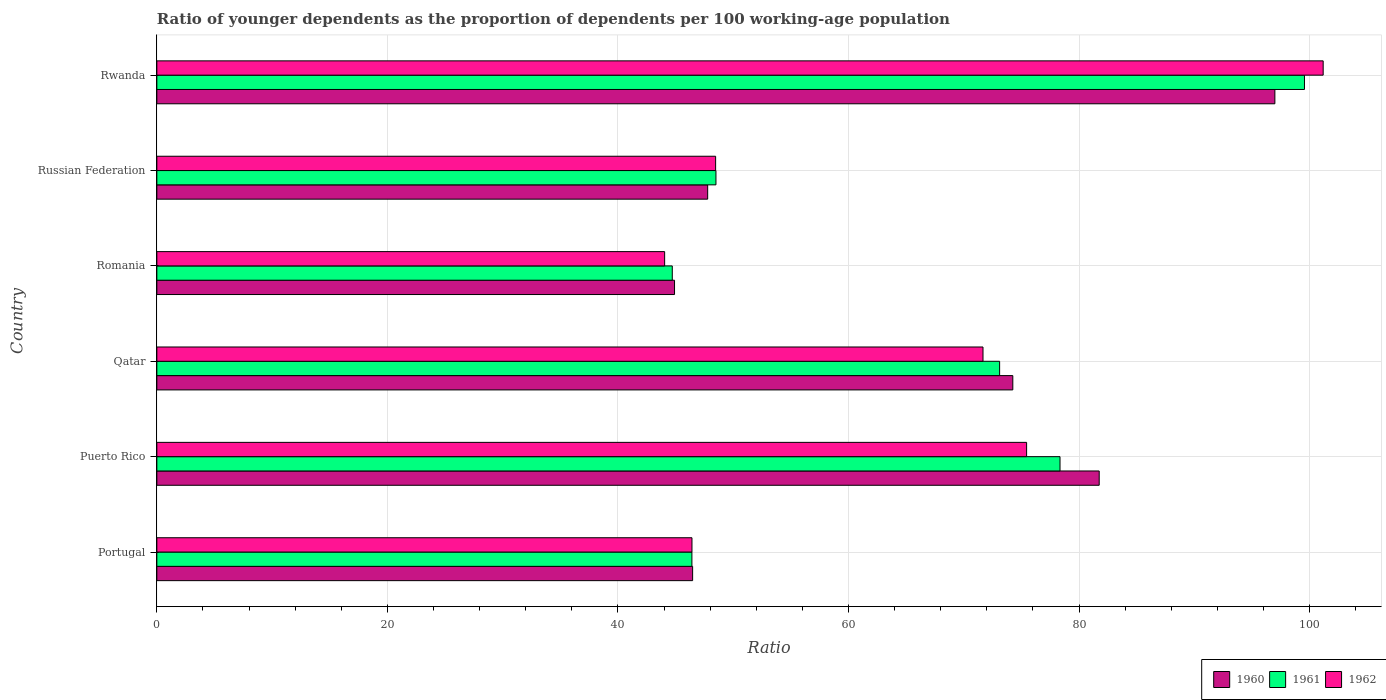How many different coloured bars are there?
Make the answer very short. 3. Are the number of bars per tick equal to the number of legend labels?
Offer a terse response. Yes. How many bars are there on the 2nd tick from the top?
Offer a terse response. 3. How many bars are there on the 6th tick from the bottom?
Offer a very short reply. 3. In how many cases, is the number of bars for a given country not equal to the number of legend labels?
Make the answer very short. 0. What is the age dependency ratio(young) in 1961 in Russian Federation?
Your answer should be compact. 48.5. Across all countries, what is the maximum age dependency ratio(young) in 1961?
Your answer should be compact. 99.56. Across all countries, what is the minimum age dependency ratio(young) in 1962?
Provide a succinct answer. 44.05. In which country was the age dependency ratio(young) in 1961 maximum?
Ensure brevity in your answer.  Rwanda. In which country was the age dependency ratio(young) in 1960 minimum?
Give a very brief answer. Romania. What is the total age dependency ratio(young) in 1962 in the graph?
Provide a succinct answer. 387.24. What is the difference between the age dependency ratio(young) in 1960 in Qatar and that in Rwanda?
Your answer should be very brief. -22.73. What is the difference between the age dependency ratio(young) in 1960 in Rwanda and the age dependency ratio(young) in 1961 in Puerto Rico?
Provide a short and direct response. 18.64. What is the average age dependency ratio(young) in 1960 per country?
Make the answer very short. 65.36. What is the difference between the age dependency ratio(young) in 1961 and age dependency ratio(young) in 1960 in Portugal?
Your answer should be very brief. -0.06. In how many countries, is the age dependency ratio(young) in 1960 greater than 72 ?
Your response must be concise. 3. What is the ratio of the age dependency ratio(young) in 1962 in Portugal to that in Rwanda?
Offer a very short reply. 0.46. Is the age dependency ratio(young) in 1961 in Qatar less than that in Rwanda?
Keep it short and to the point. Yes. What is the difference between the highest and the second highest age dependency ratio(young) in 1960?
Provide a succinct answer. 15.24. What is the difference between the highest and the lowest age dependency ratio(young) in 1960?
Ensure brevity in your answer.  52.08. Is the sum of the age dependency ratio(young) in 1960 in Romania and Russian Federation greater than the maximum age dependency ratio(young) in 1961 across all countries?
Offer a terse response. No. What does the 1st bar from the top in Russian Federation represents?
Keep it short and to the point. 1962. What does the 2nd bar from the bottom in Rwanda represents?
Your answer should be compact. 1961. Is it the case that in every country, the sum of the age dependency ratio(young) in 1962 and age dependency ratio(young) in 1961 is greater than the age dependency ratio(young) in 1960?
Offer a terse response. Yes. How many countries are there in the graph?
Keep it short and to the point. 6. What is the difference between two consecutive major ticks on the X-axis?
Provide a short and direct response. 20. Are the values on the major ticks of X-axis written in scientific E-notation?
Your answer should be very brief. No. Does the graph contain any zero values?
Provide a short and direct response. No. Does the graph contain grids?
Ensure brevity in your answer.  Yes. How many legend labels are there?
Provide a short and direct response. 3. What is the title of the graph?
Provide a succinct answer. Ratio of younger dependents as the proportion of dependents per 100 working-age population. Does "1982" appear as one of the legend labels in the graph?
Offer a terse response. No. What is the label or title of the X-axis?
Offer a terse response. Ratio. What is the Ratio in 1960 in Portugal?
Your answer should be very brief. 46.48. What is the Ratio of 1961 in Portugal?
Your answer should be very brief. 46.42. What is the Ratio in 1962 in Portugal?
Your answer should be compact. 46.42. What is the Ratio of 1960 in Puerto Rico?
Keep it short and to the point. 81.75. What is the Ratio of 1961 in Puerto Rico?
Offer a terse response. 78.35. What is the Ratio of 1962 in Puerto Rico?
Provide a succinct answer. 75.45. What is the Ratio of 1960 in Qatar?
Your answer should be compact. 74.25. What is the Ratio of 1961 in Qatar?
Offer a very short reply. 73.11. What is the Ratio of 1962 in Qatar?
Offer a terse response. 71.67. What is the Ratio of 1960 in Romania?
Your answer should be compact. 44.91. What is the Ratio in 1961 in Romania?
Your answer should be very brief. 44.71. What is the Ratio in 1962 in Romania?
Provide a short and direct response. 44.05. What is the Ratio in 1960 in Russian Federation?
Your response must be concise. 47.78. What is the Ratio of 1961 in Russian Federation?
Ensure brevity in your answer.  48.5. What is the Ratio in 1962 in Russian Federation?
Provide a short and direct response. 48.47. What is the Ratio of 1960 in Rwanda?
Keep it short and to the point. 96.99. What is the Ratio of 1961 in Rwanda?
Give a very brief answer. 99.56. What is the Ratio of 1962 in Rwanda?
Keep it short and to the point. 101.18. Across all countries, what is the maximum Ratio in 1960?
Make the answer very short. 96.99. Across all countries, what is the maximum Ratio of 1961?
Provide a succinct answer. 99.56. Across all countries, what is the maximum Ratio in 1962?
Your answer should be compact. 101.18. Across all countries, what is the minimum Ratio of 1960?
Your answer should be compact. 44.91. Across all countries, what is the minimum Ratio in 1961?
Provide a succinct answer. 44.71. Across all countries, what is the minimum Ratio of 1962?
Offer a terse response. 44.05. What is the total Ratio of 1960 in the graph?
Give a very brief answer. 392.16. What is the total Ratio in 1961 in the graph?
Ensure brevity in your answer.  390.65. What is the total Ratio in 1962 in the graph?
Ensure brevity in your answer.  387.24. What is the difference between the Ratio of 1960 in Portugal and that in Puerto Rico?
Ensure brevity in your answer.  -35.27. What is the difference between the Ratio of 1961 in Portugal and that in Puerto Rico?
Offer a terse response. -31.93. What is the difference between the Ratio in 1962 in Portugal and that in Puerto Rico?
Offer a terse response. -29.03. What is the difference between the Ratio of 1960 in Portugal and that in Qatar?
Give a very brief answer. -27.78. What is the difference between the Ratio in 1961 in Portugal and that in Qatar?
Your answer should be very brief. -26.69. What is the difference between the Ratio of 1962 in Portugal and that in Qatar?
Your answer should be compact. -25.25. What is the difference between the Ratio in 1960 in Portugal and that in Romania?
Offer a terse response. 1.57. What is the difference between the Ratio in 1961 in Portugal and that in Romania?
Offer a very short reply. 1.7. What is the difference between the Ratio in 1962 in Portugal and that in Romania?
Offer a very short reply. 2.37. What is the difference between the Ratio in 1960 in Portugal and that in Russian Federation?
Your answer should be compact. -1.31. What is the difference between the Ratio of 1961 in Portugal and that in Russian Federation?
Provide a short and direct response. -2.09. What is the difference between the Ratio in 1962 in Portugal and that in Russian Federation?
Offer a very short reply. -2.05. What is the difference between the Ratio in 1960 in Portugal and that in Rwanda?
Provide a short and direct response. -50.51. What is the difference between the Ratio in 1961 in Portugal and that in Rwanda?
Keep it short and to the point. -53.14. What is the difference between the Ratio of 1962 in Portugal and that in Rwanda?
Ensure brevity in your answer.  -54.76. What is the difference between the Ratio in 1960 in Puerto Rico and that in Qatar?
Your answer should be compact. 7.49. What is the difference between the Ratio of 1961 in Puerto Rico and that in Qatar?
Provide a short and direct response. 5.24. What is the difference between the Ratio in 1962 in Puerto Rico and that in Qatar?
Ensure brevity in your answer.  3.78. What is the difference between the Ratio in 1960 in Puerto Rico and that in Romania?
Your answer should be compact. 36.84. What is the difference between the Ratio in 1961 in Puerto Rico and that in Romania?
Make the answer very short. 33.64. What is the difference between the Ratio of 1962 in Puerto Rico and that in Romania?
Offer a terse response. 31.4. What is the difference between the Ratio in 1960 in Puerto Rico and that in Russian Federation?
Provide a succinct answer. 33.96. What is the difference between the Ratio in 1961 in Puerto Rico and that in Russian Federation?
Give a very brief answer. 29.85. What is the difference between the Ratio of 1962 in Puerto Rico and that in Russian Federation?
Your answer should be compact. 26.98. What is the difference between the Ratio in 1960 in Puerto Rico and that in Rwanda?
Your answer should be very brief. -15.24. What is the difference between the Ratio of 1961 in Puerto Rico and that in Rwanda?
Make the answer very short. -21.21. What is the difference between the Ratio of 1962 in Puerto Rico and that in Rwanda?
Offer a very short reply. -25.73. What is the difference between the Ratio in 1960 in Qatar and that in Romania?
Offer a very short reply. 29.35. What is the difference between the Ratio in 1961 in Qatar and that in Romania?
Keep it short and to the point. 28.4. What is the difference between the Ratio of 1962 in Qatar and that in Romania?
Your answer should be compact. 27.62. What is the difference between the Ratio in 1960 in Qatar and that in Russian Federation?
Ensure brevity in your answer.  26.47. What is the difference between the Ratio of 1961 in Qatar and that in Russian Federation?
Ensure brevity in your answer.  24.61. What is the difference between the Ratio of 1962 in Qatar and that in Russian Federation?
Your answer should be compact. 23.2. What is the difference between the Ratio in 1960 in Qatar and that in Rwanda?
Provide a succinct answer. -22.73. What is the difference between the Ratio in 1961 in Qatar and that in Rwanda?
Your response must be concise. -26.44. What is the difference between the Ratio of 1962 in Qatar and that in Rwanda?
Give a very brief answer. -29.51. What is the difference between the Ratio in 1960 in Romania and that in Russian Federation?
Ensure brevity in your answer.  -2.88. What is the difference between the Ratio in 1961 in Romania and that in Russian Federation?
Keep it short and to the point. -3.79. What is the difference between the Ratio of 1962 in Romania and that in Russian Federation?
Your answer should be very brief. -4.42. What is the difference between the Ratio of 1960 in Romania and that in Rwanda?
Your answer should be very brief. -52.08. What is the difference between the Ratio of 1961 in Romania and that in Rwanda?
Offer a very short reply. -54.84. What is the difference between the Ratio in 1962 in Romania and that in Rwanda?
Your answer should be very brief. -57.13. What is the difference between the Ratio of 1960 in Russian Federation and that in Rwanda?
Your response must be concise. -49.2. What is the difference between the Ratio of 1961 in Russian Federation and that in Rwanda?
Offer a terse response. -51.05. What is the difference between the Ratio of 1962 in Russian Federation and that in Rwanda?
Your answer should be compact. -52.71. What is the difference between the Ratio in 1960 in Portugal and the Ratio in 1961 in Puerto Rico?
Provide a succinct answer. -31.87. What is the difference between the Ratio of 1960 in Portugal and the Ratio of 1962 in Puerto Rico?
Make the answer very short. -28.97. What is the difference between the Ratio in 1961 in Portugal and the Ratio in 1962 in Puerto Rico?
Offer a terse response. -29.04. What is the difference between the Ratio in 1960 in Portugal and the Ratio in 1961 in Qatar?
Provide a succinct answer. -26.63. What is the difference between the Ratio of 1960 in Portugal and the Ratio of 1962 in Qatar?
Your answer should be very brief. -25.19. What is the difference between the Ratio in 1961 in Portugal and the Ratio in 1962 in Qatar?
Provide a short and direct response. -25.25. What is the difference between the Ratio in 1960 in Portugal and the Ratio in 1961 in Romania?
Ensure brevity in your answer.  1.76. What is the difference between the Ratio in 1960 in Portugal and the Ratio in 1962 in Romania?
Make the answer very short. 2.43. What is the difference between the Ratio of 1961 in Portugal and the Ratio of 1962 in Romania?
Offer a very short reply. 2.37. What is the difference between the Ratio in 1960 in Portugal and the Ratio in 1961 in Russian Federation?
Ensure brevity in your answer.  -2.02. What is the difference between the Ratio of 1960 in Portugal and the Ratio of 1962 in Russian Federation?
Make the answer very short. -1.99. What is the difference between the Ratio in 1961 in Portugal and the Ratio in 1962 in Russian Federation?
Offer a very short reply. -2.06. What is the difference between the Ratio in 1960 in Portugal and the Ratio in 1961 in Rwanda?
Give a very brief answer. -53.08. What is the difference between the Ratio of 1960 in Portugal and the Ratio of 1962 in Rwanda?
Your response must be concise. -54.7. What is the difference between the Ratio in 1961 in Portugal and the Ratio in 1962 in Rwanda?
Offer a terse response. -54.76. What is the difference between the Ratio in 1960 in Puerto Rico and the Ratio in 1961 in Qatar?
Offer a terse response. 8.64. What is the difference between the Ratio in 1960 in Puerto Rico and the Ratio in 1962 in Qatar?
Ensure brevity in your answer.  10.08. What is the difference between the Ratio in 1961 in Puerto Rico and the Ratio in 1962 in Qatar?
Keep it short and to the point. 6.68. What is the difference between the Ratio of 1960 in Puerto Rico and the Ratio of 1961 in Romania?
Ensure brevity in your answer.  37.04. What is the difference between the Ratio of 1960 in Puerto Rico and the Ratio of 1962 in Romania?
Make the answer very short. 37.7. What is the difference between the Ratio of 1961 in Puerto Rico and the Ratio of 1962 in Romania?
Give a very brief answer. 34.3. What is the difference between the Ratio in 1960 in Puerto Rico and the Ratio in 1961 in Russian Federation?
Offer a terse response. 33.25. What is the difference between the Ratio in 1960 in Puerto Rico and the Ratio in 1962 in Russian Federation?
Offer a terse response. 33.28. What is the difference between the Ratio of 1961 in Puerto Rico and the Ratio of 1962 in Russian Federation?
Your response must be concise. 29.88. What is the difference between the Ratio in 1960 in Puerto Rico and the Ratio in 1961 in Rwanda?
Offer a very short reply. -17.81. What is the difference between the Ratio in 1960 in Puerto Rico and the Ratio in 1962 in Rwanda?
Your response must be concise. -19.43. What is the difference between the Ratio in 1961 in Puerto Rico and the Ratio in 1962 in Rwanda?
Offer a terse response. -22.83. What is the difference between the Ratio in 1960 in Qatar and the Ratio in 1961 in Romania?
Your answer should be compact. 29.54. What is the difference between the Ratio in 1960 in Qatar and the Ratio in 1962 in Romania?
Provide a short and direct response. 30.2. What is the difference between the Ratio in 1961 in Qatar and the Ratio in 1962 in Romania?
Your response must be concise. 29.06. What is the difference between the Ratio of 1960 in Qatar and the Ratio of 1961 in Russian Federation?
Offer a very short reply. 25.75. What is the difference between the Ratio in 1960 in Qatar and the Ratio in 1962 in Russian Federation?
Give a very brief answer. 25.78. What is the difference between the Ratio of 1961 in Qatar and the Ratio of 1962 in Russian Federation?
Provide a succinct answer. 24.64. What is the difference between the Ratio in 1960 in Qatar and the Ratio in 1961 in Rwanda?
Your answer should be very brief. -25.3. What is the difference between the Ratio in 1960 in Qatar and the Ratio in 1962 in Rwanda?
Ensure brevity in your answer.  -26.92. What is the difference between the Ratio in 1961 in Qatar and the Ratio in 1962 in Rwanda?
Offer a terse response. -28.07. What is the difference between the Ratio of 1960 in Romania and the Ratio of 1961 in Russian Federation?
Provide a succinct answer. -3.59. What is the difference between the Ratio in 1960 in Romania and the Ratio in 1962 in Russian Federation?
Your answer should be very brief. -3.56. What is the difference between the Ratio in 1961 in Romania and the Ratio in 1962 in Russian Federation?
Ensure brevity in your answer.  -3.76. What is the difference between the Ratio in 1960 in Romania and the Ratio in 1961 in Rwanda?
Your response must be concise. -54.65. What is the difference between the Ratio in 1960 in Romania and the Ratio in 1962 in Rwanda?
Give a very brief answer. -56.27. What is the difference between the Ratio in 1961 in Romania and the Ratio in 1962 in Rwanda?
Offer a very short reply. -56.47. What is the difference between the Ratio in 1960 in Russian Federation and the Ratio in 1961 in Rwanda?
Offer a very short reply. -51.77. What is the difference between the Ratio of 1960 in Russian Federation and the Ratio of 1962 in Rwanda?
Provide a succinct answer. -53.39. What is the difference between the Ratio in 1961 in Russian Federation and the Ratio in 1962 in Rwanda?
Ensure brevity in your answer.  -52.68. What is the average Ratio of 1960 per country?
Make the answer very short. 65.36. What is the average Ratio in 1961 per country?
Give a very brief answer. 65.11. What is the average Ratio in 1962 per country?
Ensure brevity in your answer.  64.54. What is the difference between the Ratio of 1960 and Ratio of 1961 in Portugal?
Ensure brevity in your answer.  0.06. What is the difference between the Ratio of 1960 and Ratio of 1962 in Portugal?
Provide a short and direct response. 0.06. What is the difference between the Ratio in 1961 and Ratio in 1962 in Portugal?
Ensure brevity in your answer.  -0.01. What is the difference between the Ratio of 1960 and Ratio of 1961 in Puerto Rico?
Your answer should be very brief. 3.4. What is the difference between the Ratio of 1960 and Ratio of 1962 in Puerto Rico?
Make the answer very short. 6.3. What is the difference between the Ratio of 1961 and Ratio of 1962 in Puerto Rico?
Offer a terse response. 2.9. What is the difference between the Ratio of 1960 and Ratio of 1961 in Qatar?
Make the answer very short. 1.14. What is the difference between the Ratio of 1960 and Ratio of 1962 in Qatar?
Keep it short and to the point. 2.59. What is the difference between the Ratio of 1961 and Ratio of 1962 in Qatar?
Ensure brevity in your answer.  1.44. What is the difference between the Ratio in 1960 and Ratio in 1961 in Romania?
Your answer should be compact. 0.2. What is the difference between the Ratio in 1960 and Ratio in 1962 in Romania?
Provide a succinct answer. 0.86. What is the difference between the Ratio in 1961 and Ratio in 1962 in Romania?
Ensure brevity in your answer.  0.66. What is the difference between the Ratio of 1960 and Ratio of 1961 in Russian Federation?
Offer a very short reply. -0.72. What is the difference between the Ratio in 1960 and Ratio in 1962 in Russian Federation?
Give a very brief answer. -0.69. What is the difference between the Ratio in 1961 and Ratio in 1962 in Russian Federation?
Ensure brevity in your answer.  0.03. What is the difference between the Ratio of 1960 and Ratio of 1961 in Rwanda?
Ensure brevity in your answer.  -2.57. What is the difference between the Ratio of 1960 and Ratio of 1962 in Rwanda?
Your response must be concise. -4.19. What is the difference between the Ratio in 1961 and Ratio in 1962 in Rwanda?
Ensure brevity in your answer.  -1.62. What is the ratio of the Ratio in 1960 in Portugal to that in Puerto Rico?
Ensure brevity in your answer.  0.57. What is the ratio of the Ratio in 1961 in Portugal to that in Puerto Rico?
Your answer should be very brief. 0.59. What is the ratio of the Ratio of 1962 in Portugal to that in Puerto Rico?
Give a very brief answer. 0.62. What is the ratio of the Ratio of 1960 in Portugal to that in Qatar?
Ensure brevity in your answer.  0.63. What is the ratio of the Ratio of 1961 in Portugal to that in Qatar?
Offer a very short reply. 0.63. What is the ratio of the Ratio of 1962 in Portugal to that in Qatar?
Keep it short and to the point. 0.65. What is the ratio of the Ratio of 1960 in Portugal to that in Romania?
Provide a short and direct response. 1.03. What is the ratio of the Ratio of 1961 in Portugal to that in Romania?
Offer a terse response. 1.04. What is the ratio of the Ratio of 1962 in Portugal to that in Romania?
Your response must be concise. 1.05. What is the ratio of the Ratio in 1960 in Portugal to that in Russian Federation?
Your answer should be compact. 0.97. What is the ratio of the Ratio of 1961 in Portugal to that in Russian Federation?
Your answer should be very brief. 0.96. What is the ratio of the Ratio in 1962 in Portugal to that in Russian Federation?
Ensure brevity in your answer.  0.96. What is the ratio of the Ratio of 1960 in Portugal to that in Rwanda?
Your answer should be compact. 0.48. What is the ratio of the Ratio in 1961 in Portugal to that in Rwanda?
Give a very brief answer. 0.47. What is the ratio of the Ratio of 1962 in Portugal to that in Rwanda?
Your answer should be very brief. 0.46. What is the ratio of the Ratio in 1960 in Puerto Rico to that in Qatar?
Your answer should be very brief. 1.1. What is the ratio of the Ratio in 1961 in Puerto Rico to that in Qatar?
Offer a terse response. 1.07. What is the ratio of the Ratio in 1962 in Puerto Rico to that in Qatar?
Offer a very short reply. 1.05. What is the ratio of the Ratio of 1960 in Puerto Rico to that in Romania?
Your answer should be very brief. 1.82. What is the ratio of the Ratio of 1961 in Puerto Rico to that in Romania?
Your answer should be compact. 1.75. What is the ratio of the Ratio of 1962 in Puerto Rico to that in Romania?
Make the answer very short. 1.71. What is the ratio of the Ratio in 1960 in Puerto Rico to that in Russian Federation?
Your answer should be compact. 1.71. What is the ratio of the Ratio in 1961 in Puerto Rico to that in Russian Federation?
Offer a very short reply. 1.62. What is the ratio of the Ratio in 1962 in Puerto Rico to that in Russian Federation?
Your answer should be compact. 1.56. What is the ratio of the Ratio in 1960 in Puerto Rico to that in Rwanda?
Offer a terse response. 0.84. What is the ratio of the Ratio in 1961 in Puerto Rico to that in Rwanda?
Your response must be concise. 0.79. What is the ratio of the Ratio of 1962 in Puerto Rico to that in Rwanda?
Your response must be concise. 0.75. What is the ratio of the Ratio in 1960 in Qatar to that in Romania?
Offer a terse response. 1.65. What is the ratio of the Ratio in 1961 in Qatar to that in Romania?
Offer a terse response. 1.64. What is the ratio of the Ratio in 1962 in Qatar to that in Romania?
Give a very brief answer. 1.63. What is the ratio of the Ratio of 1960 in Qatar to that in Russian Federation?
Keep it short and to the point. 1.55. What is the ratio of the Ratio of 1961 in Qatar to that in Russian Federation?
Provide a short and direct response. 1.51. What is the ratio of the Ratio of 1962 in Qatar to that in Russian Federation?
Keep it short and to the point. 1.48. What is the ratio of the Ratio of 1960 in Qatar to that in Rwanda?
Provide a succinct answer. 0.77. What is the ratio of the Ratio in 1961 in Qatar to that in Rwanda?
Provide a short and direct response. 0.73. What is the ratio of the Ratio in 1962 in Qatar to that in Rwanda?
Ensure brevity in your answer.  0.71. What is the ratio of the Ratio of 1960 in Romania to that in Russian Federation?
Keep it short and to the point. 0.94. What is the ratio of the Ratio in 1961 in Romania to that in Russian Federation?
Offer a very short reply. 0.92. What is the ratio of the Ratio in 1962 in Romania to that in Russian Federation?
Provide a succinct answer. 0.91. What is the ratio of the Ratio in 1960 in Romania to that in Rwanda?
Your answer should be compact. 0.46. What is the ratio of the Ratio of 1961 in Romania to that in Rwanda?
Your answer should be compact. 0.45. What is the ratio of the Ratio of 1962 in Romania to that in Rwanda?
Provide a succinct answer. 0.44. What is the ratio of the Ratio of 1960 in Russian Federation to that in Rwanda?
Make the answer very short. 0.49. What is the ratio of the Ratio in 1961 in Russian Federation to that in Rwanda?
Your response must be concise. 0.49. What is the ratio of the Ratio in 1962 in Russian Federation to that in Rwanda?
Your answer should be compact. 0.48. What is the difference between the highest and the second highest Ratio of 1960?
Give a very brief answer. 15.24. What is the difference between the highest and the second highest Ratio of 1961?
Make the answer very short. 21.21. What is the difference between the highest and the second highest Ratio in 1962?
Give a very brief answer. 25.73. What is the difference between the highest and the lowest Ratio of 1960?
Provide a succinct answer. 52.08. What is the difference between the highest and the lowest Ratio of 1961?
Ensure brevity in your answer.  54.84. What is the difference between the highest and the lowest Ratio of 1962?
Ensure brevity in your answer.  57.13. 